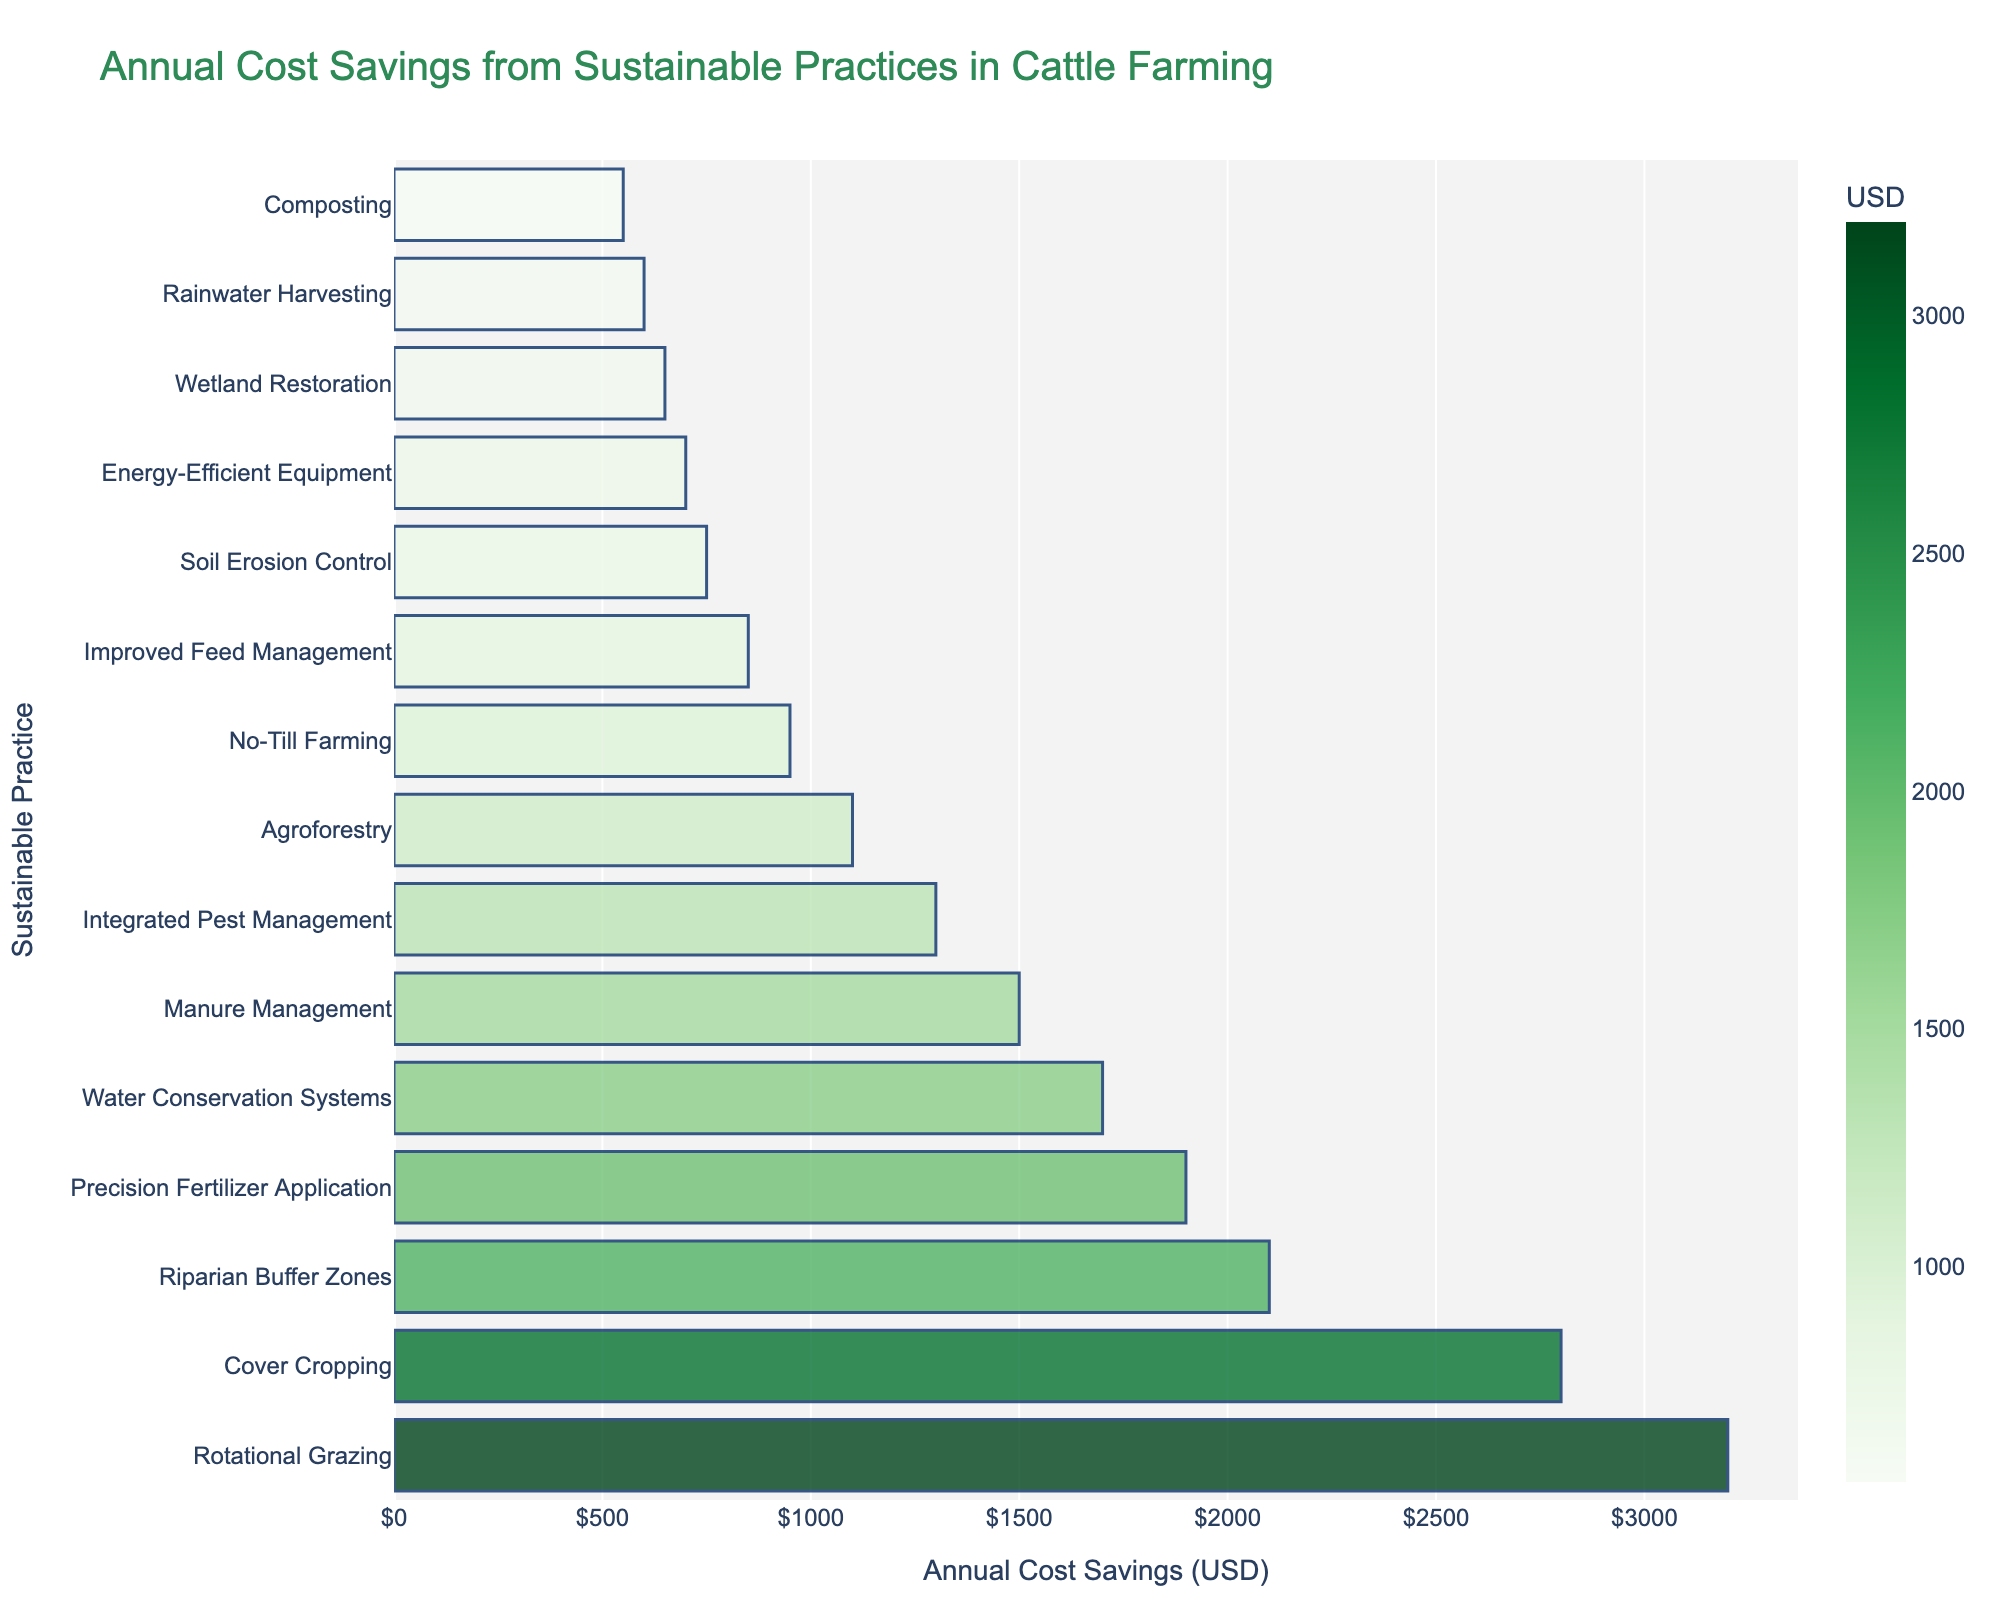Which sustainable practice has the highest annual cost savings? The bar representing Rotational Grazing is the longest, indicating the highest annual cost savings.
Answer: Rotational Grazing Which two sustainable practices together save the most annually? Adding the two highest cost savings, Rotational Grazing ($3200) and Cover Cropping ($2800), gives the highest combined savings.
Answer: Rotational Grazing and Cover Cropping How much more is saved annually by implementing Rotational Grazing compared to Soil Erosion Control? Subtract the savings of Soil Erosion Control from Rotational Grazing: $3200 - $750 = $2450.
Answer: $2450 What's the combined annual cost savings of the top three practices? The top three practices are Rotational Grazing, Cover Cropping, and Riparian Buffer Zones, with savings of $3200, $2800, and $2100, respectively. Adding these: $3200 + $2800 + $2100 = $8100.
Answer: $8100 Which sustainable practice has the lowest annual cost savings? The bar representing Composting is the shortest, indicating the lowest annual cost savings.
Answer: Composting Which practice saves more annually, Precision Fertilizer Application or Manure Management, and by how much? Precision Fertilizer Application saves $1900, and Manure Management saves $1500. Subtracting the two: $1900 - $1500 = $400.
Answer: Precision Fertilizer Application by $400 What is the total annual cost savings for all the practices listed? Sum the annual cost savings of all practices: $3200 + $2800 + $2100 + $1900 + $1700 + $1500 + $1300 + $1100 + $950 + $850 + $750 + $700 + $650 + $600 + $550 = $21450.
Answer: $21450 How does the cost savings from Agroforestry compare to that from No-Till Farming? Agroforestry saves $1100 annually and No-Till Farming saves $950. Agroforestry saves $150 more ($1100 - $950).
Answer: Agroforestry saves $150 more Which practice's savings are closest to the average annual savings of all the practices? Calculate the average annual savings: $21450 / 15 = $1430. The closest saving to this is Integrated Pest Management at $1300.
Answer: Integrated Pest Management What is the difference in annual cost savings between the highest and lowest practices? Subtract the savings of Composting ($550) from Rotational Grazing ($3200): $3200 - $550 = $2650.
Answer: $2650 